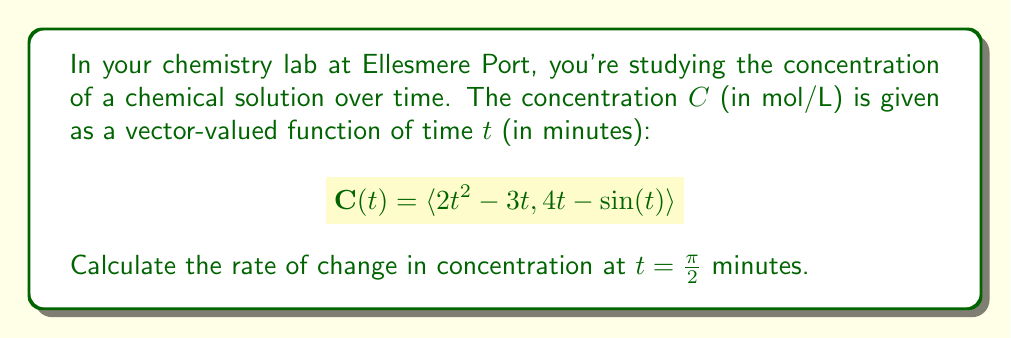Can you solve this math problem? To find the rate of change in concentration, we need to calculate the derivative of the vector-valued function $\mathbf{C}(t)$ with respect to time and then evaluate it at $t = \frac{\pi}{2}$.

Step 1: Calculate the derivative of $\mathbf{C}(t)$.
$$\frac{d}{dt}\mathbf{C}(t) = \langle \frac{d}{dt}(2t^2 - 3t), \frac{d}{dt}(4t - \sin(t)) \rangle$$

Step 2: Apply differentiation rules.
$$\frac{d}{dt}\mathbf{C}(t) = \langle 4t - 3, 4 - \cos(t) \rangle$$

Step 3: Evaluate the derivative at $t = \frac{\pi}{2}$.
$$\frac{d}{dt}\mathbf{C}(\frac{\pi}{2}) = \langle 4(\frac{\pi}{2}) - 3, 4 - \cos(\frac{\pi}{2}) \rangle$$

Step 4: Simplify.
$$\frac{d}{dt}\mathbf{C}(\frac{\pi}{2}) = \langle 2\pi - 3, 5 \rangle$$

This vector represents the rate of change in concentration at $t = \frac{\pi}{2}$ minutes. The first component $(2\pi - 3)$ represents the rate of change in the first part of the concentration function, and the second component $(5)$ represents the rate of change in the second part.
Answer: $\langle 2\pi - 3, 5 \rangle$ mol/(L·min) 